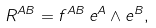<formula> <loc_0><loc_0><loc_500><loc_500>R ^ { A B } = f ^ { A B } \, e ^ { A } \wedge e ^ { B } ,</formula> 